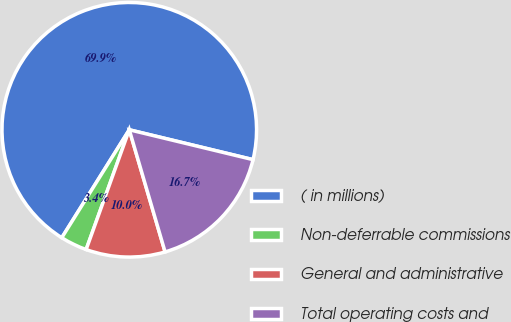<chart> <loc_0><loc_0><loc_500><loc_500><pie_chart><fcel>( in millions)<fcel>Non-deferrable commissions<fcel>General and administrative<fcel>Total operating costs and<nl><fcel>69.87%<fcel>3.39%<fcel>10.04%<fcel>16.69%<nl></chart> 